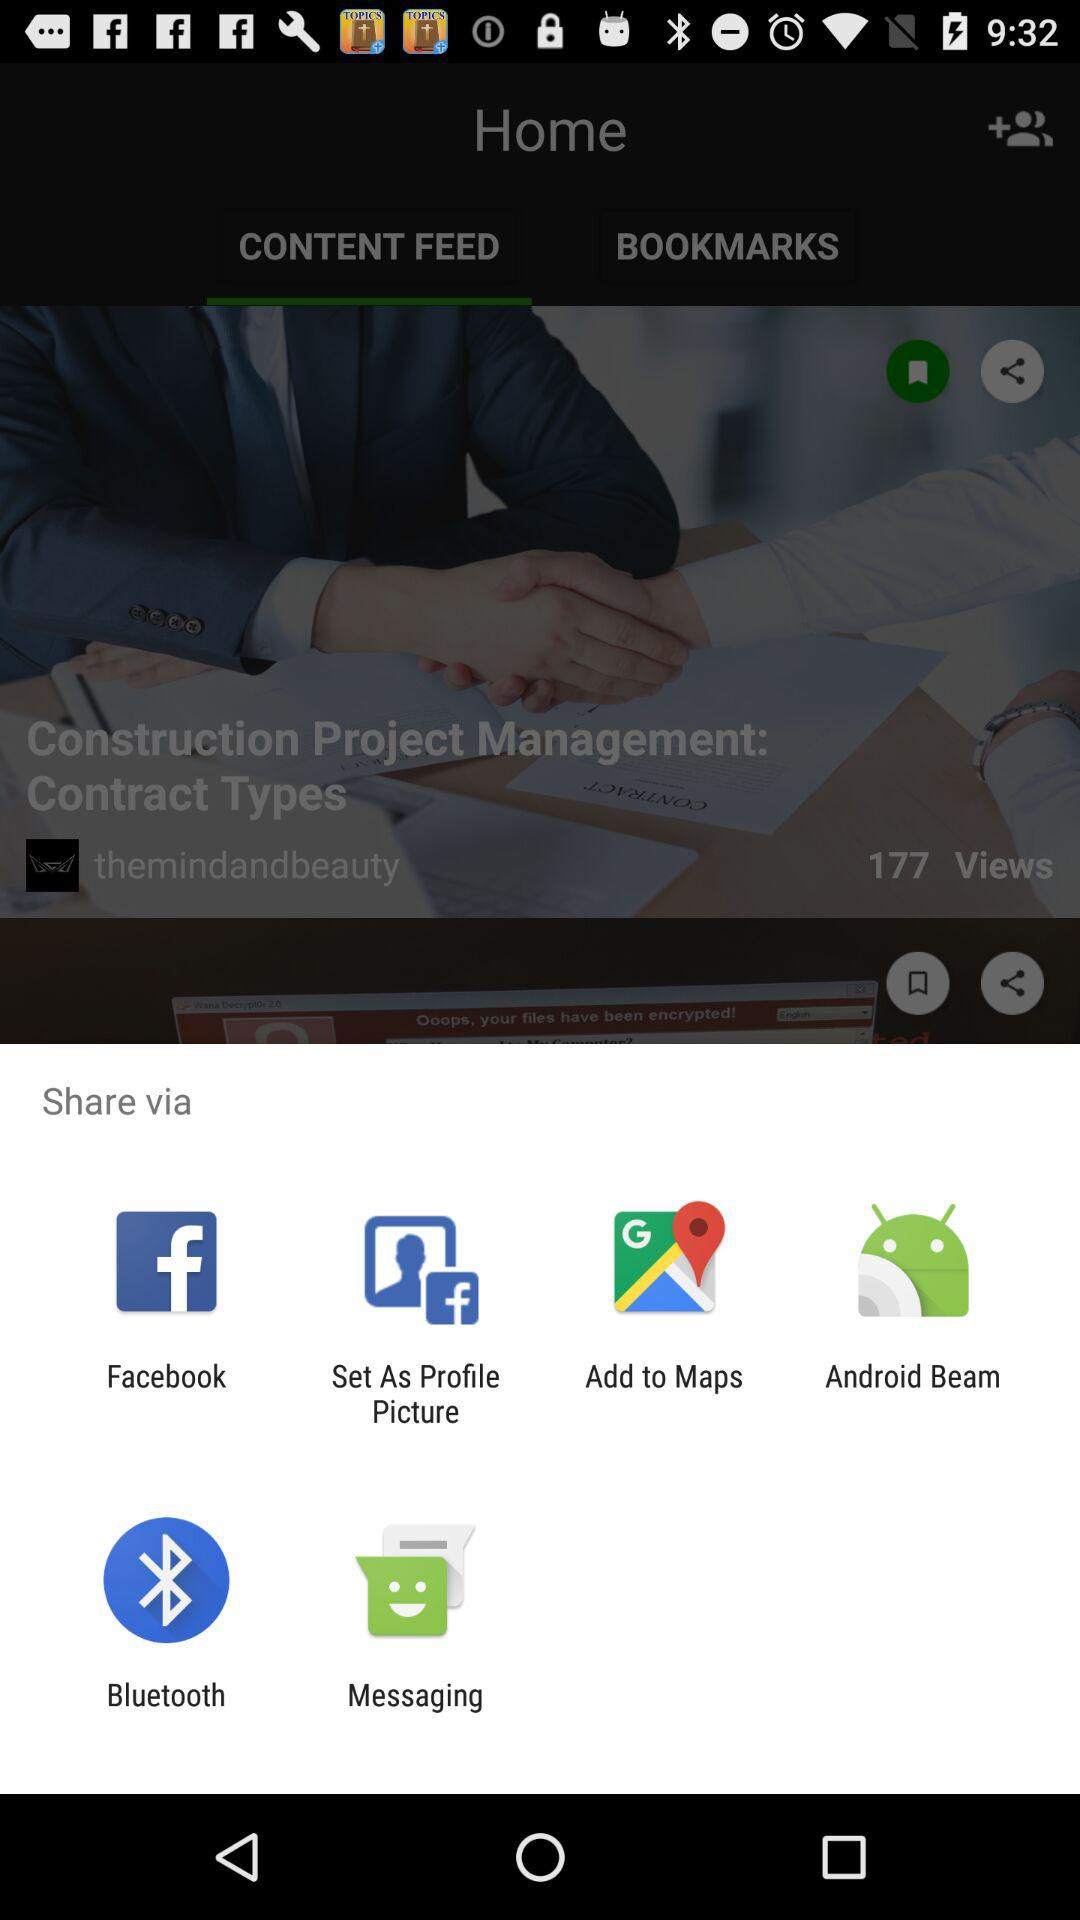Through which app can I share? You can share through "Facebook", "Set As Profile Picture", "Add to Maps", "Android Beam", "Bluetooth" and "Messaging". 